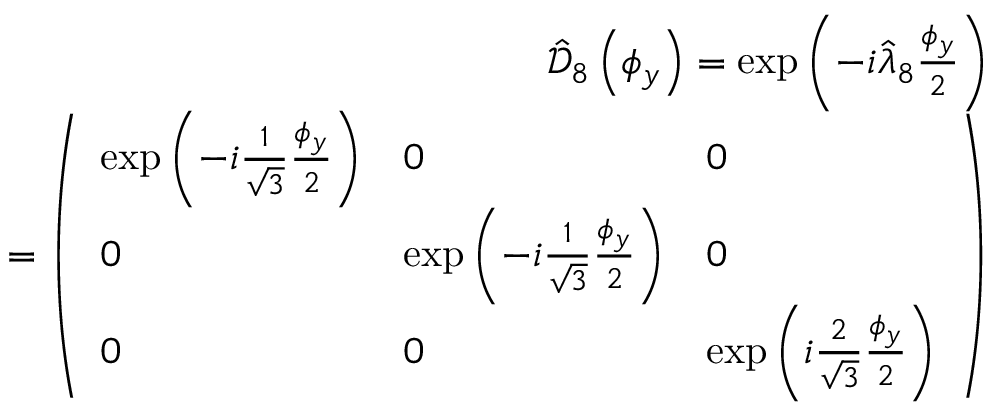<formula> <loc_0><loc_0><loc_500><loc_500>\begin{array} { r l r } & { \hat { \mathcal { D } } _ { 8 } \left ( \phi _ { y } \right ) = \exp \left ( - i \hat { \lambda } _ { 8 } \frac { \phi _ { y } } { 2 } \right ) } \\ & { = \left ( \begin{array} { l l l } { \exp \left ( - i \frac { 1 } { \sqrt { 3 } } \frac { \phi _ { y } } { 2 } \right ) } & { 0 } & { 0 } \\ { 0 } & { \exp \left ( - i \frac { 1 } { \sqrt { 3 } } \frac { \phi _ { y } } { 2 } \right ) } & { 0 } \\ { 0 } & { 0 } & { \exp \left ( i \frac { 2 } { \sqrt { 3 } } \frac { \phi _ { y } } { 2 } \right ) } \end{array} \right ) } \end{array}</formula> 